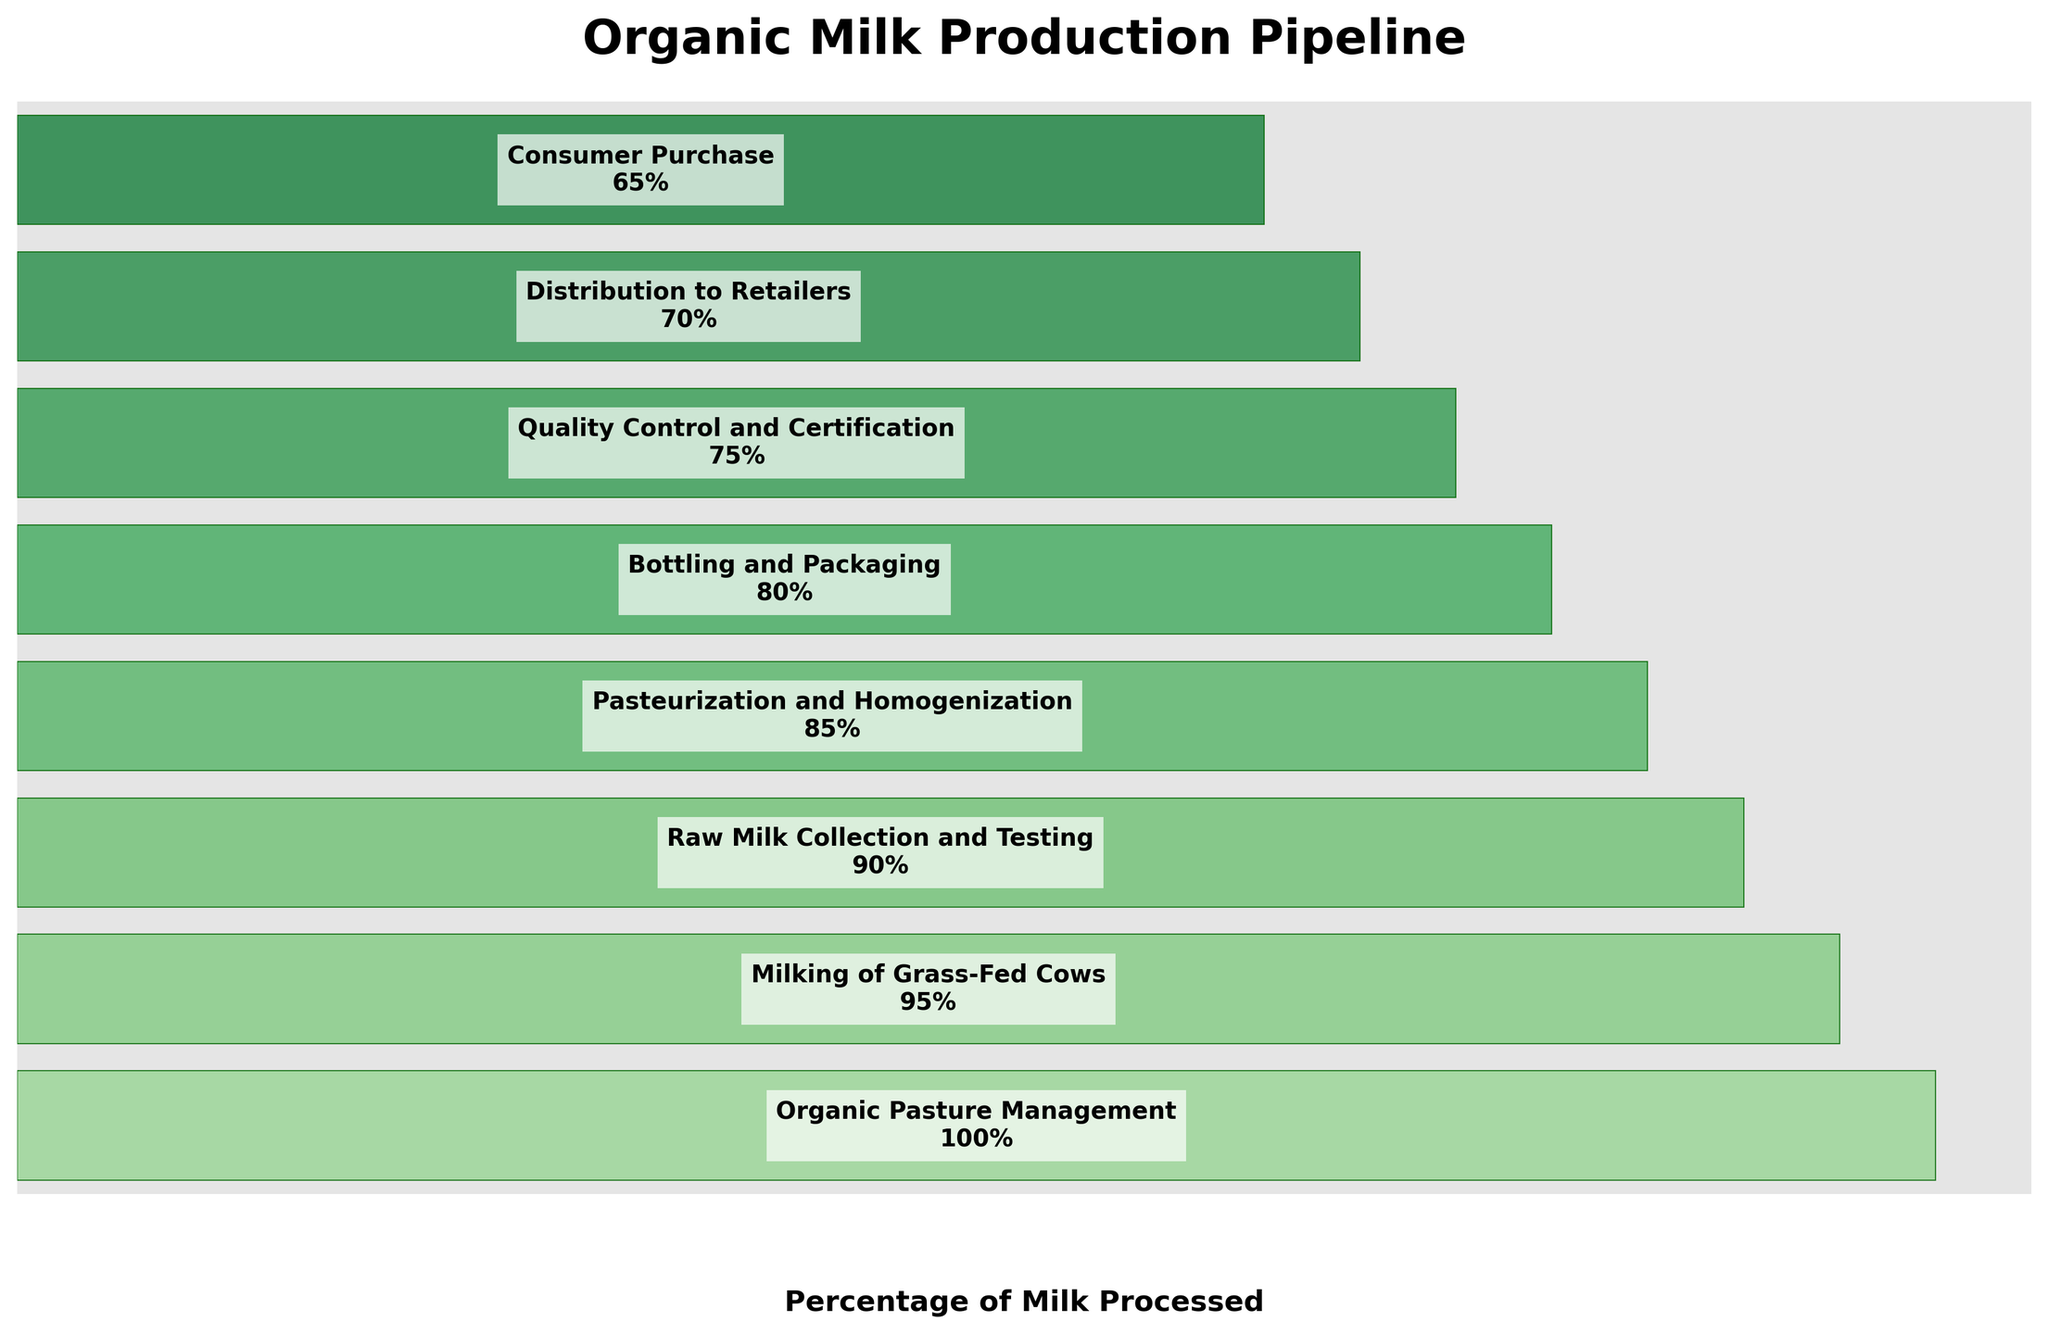what is the title of the figure? The title of the figure is displayed at the top of the chart. We can see that it indicates the overall topic of the funnel chart.
Answer: Organic Milk Production Pipeline How many stages are there in the organic milk production pipeline? By counting the number of labeled bars or segments in the funnel chart, we determine the total number of stages displayed.
Answer: 8 At what stage does the milk undergo pasteurization and homogenization? By examining the labels of each stage in the funnel chart, we find the one labeled Pasteurization and Homogenization along with its position.
Answer: Stage 4 What percentage of milk is processed at the stage "Quality Control and Certification"? Here, we look at the percentage value associated with the Quality Control and Certification stage on the funnel chart.
Answer: 75% Which stage involves the highest percentage of milk processing? By comparing the percentage values of all the stages, we see that the stage with the highest percentage is the initial one on the funnel chart.
Answer: Organic Pasture Management How much milk is lost between the "Milking of Grass-Fed Cows" and "Raw Milk Collection and Testing" stages? Subtract the percentage of Raw Milk Collection and Testing from the percentage of Milking of Grass-Fed Cows to find the difference in milk volume processed.
Answer: 5% On average, what is the percentage of milk processed in the later three stages? Average the percentages of the last three stages: (80 + 75 + 70 + 65) / 4 gives the required average.
Answer: 72.5% Is the percentage of milk processed during "Bottling and Packaging" higher or lower than during "Pasteurization and Homogenization"? We compare the percentage values of these two stages.
Answer: Lower What’s the total percentage reduction in milk processing from the first to the last stage? Subtract the percentage at the final stage (Consumer Purchase) from the initial stage (Organic Pasture Management) to find the total reduction.
Answer: 35% Which stage involves the least percentage of milk processing before reaching consumers? The stage with the lowest percentage value, which is the final stage in the funnel chart, handles the least volume of milk.
Answer: Consumer Purchase 